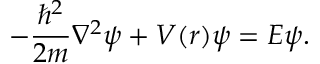Convert formula to latex. <formula><loc_0><loc_0><loc_500><loc_500>- \frac { \hbar { ^ } { 2 } } { 2 m } \nabla ^ { 2 } \psi + V ( r ) \psi = E \psi .</formula> 